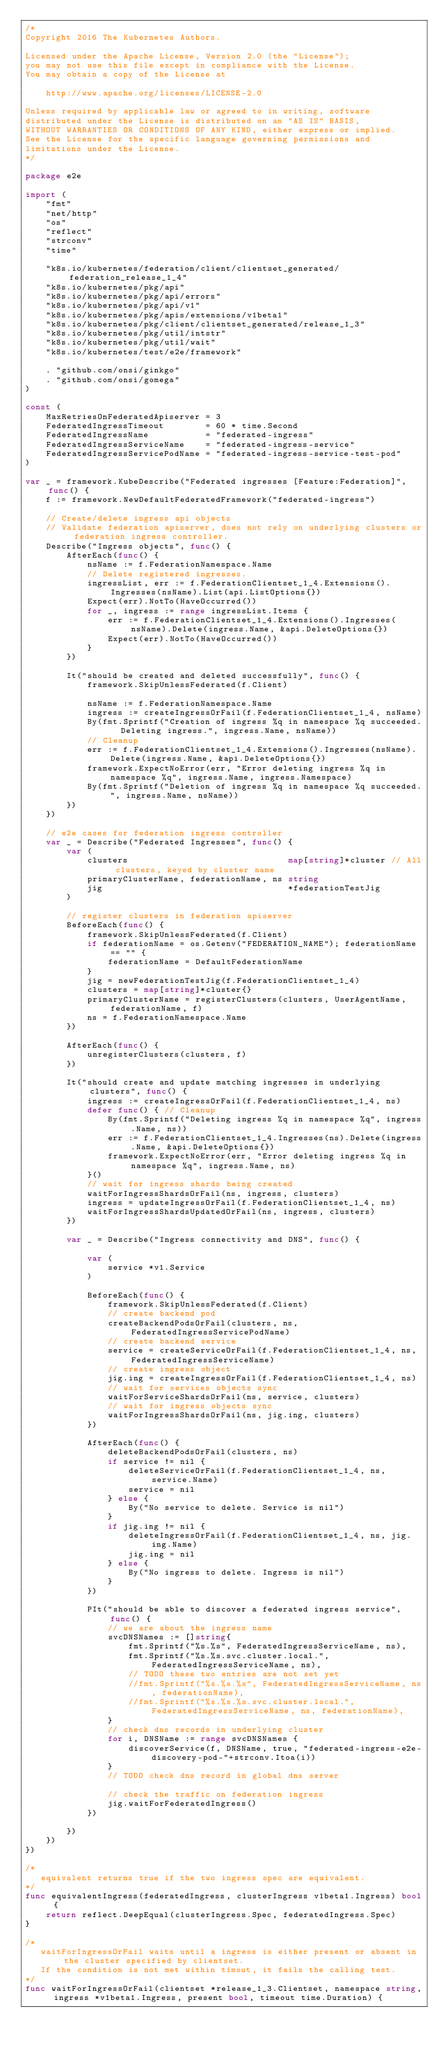Convert code to text. <code><loc_0><loc_0><loc_500><loc_500><_Go_>/*
Copyright 2016 The Kubernetes Authors.

Licensed under the Apache License, Version 2.0 (the "License");
you may not use this file except in compliance with the License.
You may obtain a copy of the License at

    http://www.apache.org/licenses/LICENSE-2.0

Unless required by applicable law or agreed to in writing, software
distributed under the License is distributed on an "AS IS" BASIS,
WITHOUT WARRANTIES OR CONDITIONS OF ANY KIND, either express or implied.
See the License for the specific language governing permissions and
limitations under the License.
*/

package e2e

import (
	"fmt"
	"net/http"
	"os"
	"reflect"
	"strconv"
	"time"

	"k8s.io/kubernetes/federation/client/clientset_generated/federation_release_1_4"
	"k8s.io/kubernetes/pkg/api"
	"k8s.io/kubernetes/pkg/api/errors"
	"k8s.io/kubernetes/pkg/api/v1"
	"k8s.io/kubernetes/pkg/apis/extensions/v1beta1"
	"k8s.io/kubernetes/pkg/client/clientset_generated/release_1_3"
	"k8s.io/kubernetes/pkg/util/intstr"
	"k8s.io/kubernetes/pkg/util/wait"
	"k8s.io/kubernetes/test/e2e/framework"

	. "github.com/onsi/ginkgo"
	. "github.com/onsi/gomega"
)

const (
	MaxRetriesOnFederatedApiserver = 3
	FederatedIngressTimeout        = 60 * time.Second
	FederatedIngressName           = "federated-ingress"
	FederatedIngressServiceName    = "federated-ingress-service"
	FederatedIngressServicePodName = "federated-ingress-service-test-pod"
)

var _ = framework.KubeDescribe("Federated ingresses [Feature:Federation]", func() {
	f := framework.NewDefaultFederatedFramework("federated-ingress")

	// Create/delete ingress api objects
	// Validate federation apiserver, does not rely on underlying clusters or federation ingress controller.
	Describe("Ingress objects", func() {
		AfterEach(func() {
			nsName := f.FederationNamespace.Name
			// Delete registered ingresses.
			ingressList, err := f.FederationClientset_1_4.Extensions().Ingresses(nsName).List(api.ListOptions{})
			Expect(err).NotTo(HaveOccurred())
			for _, ingress := range ingressList.Items {
				err := f.FederationClientset_1_4.Extensions().Ingresses(nsName).Delete(ingress.Name, &api.DeleteOptions{})
				Expect(err).NotTo(HaveOccurred())
			}
		})

		It("should be created and deleted successfully", func() {
			framework.SkipUnlessFederated(f.Client)

			nsName := f.FederationNamespace.Name
			ingress := createIngressOrFail(f.FederationClientset_1_4, nsName)
			By(fmt.Sprintf("Creation of ingress %q in namespace %q succeeded.  Deleting ingress.", ingress.Name, nsName))
			// Cleanup
			err := f.FederationClientset_1_4.Extensions().Ingresses(nsName).Delete(ingress.Name, &api.DeleteOptions{})
			framework.ExpectNoError(err, "Error deleting ingress %q in namespace %q", ingress.Name, ingress.Namespace)
			By(fmt.Sprintf("Deletion of ingress %q in namespace %q succeeded.", ingress.Name, nsName))
		})
	})

	// e2e cases for federation ingress controller
	var _ = Describe("Federated Ingresses", func() {
		var (
			clusters                               map[string]*cluster // All clusters, keyed by cluster name
			primaryClusterName, federationName, ns string
			jig                                    *federationTestJig
		)

		// register clusters in federation apiserver
		BeforeEach(func() {
			framework.SkipUnlessFederated(f.Client)
			if federationName = os.Getenv("FEDERATION_NAME"); federationName == "" {
				federationName = DefaultFederationName
			}
			jig = newFederationTestJig(f.FederationClientset_1_4)
			clusters = map[string]*cluster{}
			primaryClusterName = registerClusters(clusters, UserAgentName, federationName, f)
			ns = f.FederationNamespace.Name
		})

		AfterEach(func() {
			unregisterClusters(clusters, f)
		})

		It("should create and update matching ingresses in underlying clusters", func() {
			ingress := createIngressOrFail(f.FederationClientset_1_4, ns)
			defer func() { // Cleanup
				By(fmt.Sprintf("Deleting ingress %q in namespace %q", ingress.Name, ns))
				err := f.FederationClientset_1_4.Ingresses(ns).Delete(ingress.Name, &api.DeleteOptions{})
				framework.ExpectNoError(err, "Error deleting ingress %q in namespace %q", ingress.Name, ns)
			}()
			// wait for ingress shards being created
			waitForIngressShardsOrFail(ns, ingress, clusters)
			ingress = updateIngressOrFail(f.FederationClientset_1_4, ns)
			waitForIngressShardsUpdatedOrFail(ns, ingress, clusters)
		})

		var _ = Describe("Ingress connectivity and DNS", func() {

			var (
				service *v1.Service
			)

			BeforeEach(func() {
				framework.SkipUnlessFederated(f.Client)
				// create backend pod
				createBackendPodsOrFail(clusters, ns, FederatedIngressServicePodName)
				// create backend service
				service = createServiceOrFail(f.FederationClientset_1_4, ns, FederatedIngressServiceName)
				// create ingress object
				jig.ing = createIngressOrFail(f.FederationClientset_1_4, ns)
				// wait for services objects sync
				waitForServiceShardsOrFail(ns, service, clusters)
				// wait for ingress objects sync
				waitForIngressShardsOrFail(ns, jig.ing, clusters)
			})

			AfterEach(func() {
				deleteBackendPodsOrFail(clusters, ns)
				if service != nil {
					deleteServiceOrFail(f.FederationClientset_1_4, ns, service.Name)
					service = nil
				} else {
					By("No service to delete. Service is nil")
				}
				if jig.ing != nil {
					deleteIngressOrFail(f.FederationClientset_1_4, ns, jig.ing.Name)
					jig.ing = nil
				} else {
					By("No ingress to delete. Ingress is nil")
				}
			})

			PIt("should be able to discover a federated ingress service", func() {
				// we are about the ingress name
				svcDNSNames := []string{
					fmt.Sprintf("%s.%s", FederatedIngressServiceName, ns),
					fmt.Sprintf("%s.%s.svc.cluster.local.", FederatedIngressServiceName, ns),
					// TODO these two entries are not set yet
					//fmt.Sprintf("%s.%s.%s", FederatedIngressServiceName, ns, federationName),
					//fmt.Sprintf("%s.%s.%s.svc.cluster.local.", FederatedIngressServiceName, ns, federationName),
				}
				// check dns records in underlying cluster
				for i, DNSName := range svcDNSNames {
					discoverService(f, DNSName, true, "federated-ingress-e2e-discovery-pod-"+strconv.Itoa(i))
				}
				// TODO check dns record in global dns server

				// check the traffic on federation ingress
				jig.waitForFederatedIngress()
			})

		})
	})
})

/*
   equivalent returns true if the two ingress spec are equivalent.
*/
func equivalentIngress(federatedIngress, clusterIngress v1beta1.Ingress) bool {
	return reflect.DeepEqual(clusterIngress.Spec, federatedIngress.Spec)
}

/*
   waitForIngressOrFail waits until a ingress is either present or absent in the cluster specified by clientset.
   If the condition is not met within timout, it fails the calling test.
*/
func waitForIngressOrFail(clientset *release_1_3.Clientset, namespace string, ingress *v1beta1.Ingress, present bool, timeout time.Duration) {</code> 